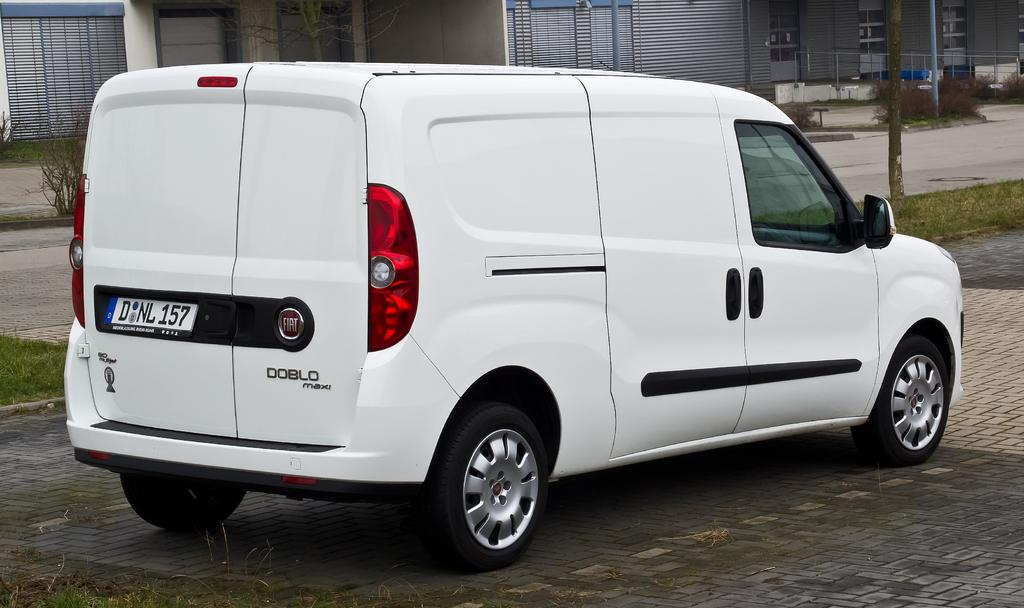What is the main object in the image? There is a car in the image. What can be seen behind the car? There is grass behind the car. Where is the grass located? The grass is on the ground. What type of structure is visible in the image? There are walls with glass doors in the image. What might be used for safety or support in the image? There is a railing in the image. What type of sign can be seen hanging from the railing in the image? There is no sign hanging from the railing in the image. Can you hear anyone coughing in the image? The image is silent, and there is no indication of anyone coughing. 